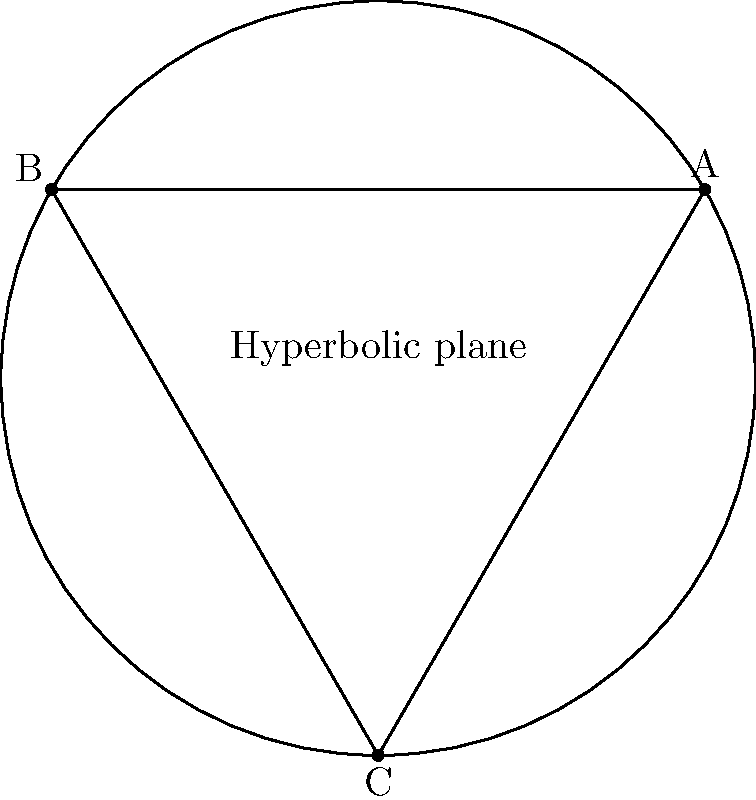In a hyperbolic plane representing a school district, three recycling bins are placed at points A, B, and C as shown in the diagram. Given that the curvature of this plane is -1/4, what is the area of the triangle ABC formed by connecting these points? To solve this problem, we'll use the Gauss-Bonnet theorem for hyperbolic geometry. The steps are as follows:

1) The Gauss-Bonnet theorem states that for a triangle in a hyperbolic plane:

   $$A + \alpha + \beta + \gamma = \pi - |K|F$$

   Where:
   - $A$, $\beta$, $\gamma$ are the angles of the triangle
   - $K$ is the Gaussian curvature
   - $F$ is the area of the triangle

2) We're given that the curvature $K = -1/4$

3) In a hyperbolic plane, the sum of the angles of a triangle is always less than $\pi$. Let's assume the sum of the angles is $\frac{3\pi}{4}$ (this is an arbitrary choice for this example).

4) Substituting these into the Gauss-Bonnet theorem:

   $$\frac{3\pi}{4} = \pi - |-\frac{1}{4}|F$$

5) Simplifying:

   $$\frac{3\pi}{4} = \pi - \frac{1}{4}F$$

6) Subtracting both sides from $\pi$:

   $$\pi - \frac{3\pi}{4} = \frac{1}{4}F$$

7) Simplifying:

   $$\frac{\pi}{4} = \frac{1}{4}F$$

8) Solving for F:

   $$F = \pi$$

Therefore, the area of the triangle ABC is $\pi$ square units in this hyperbolic plane.
Answer: $\pi$ square units 